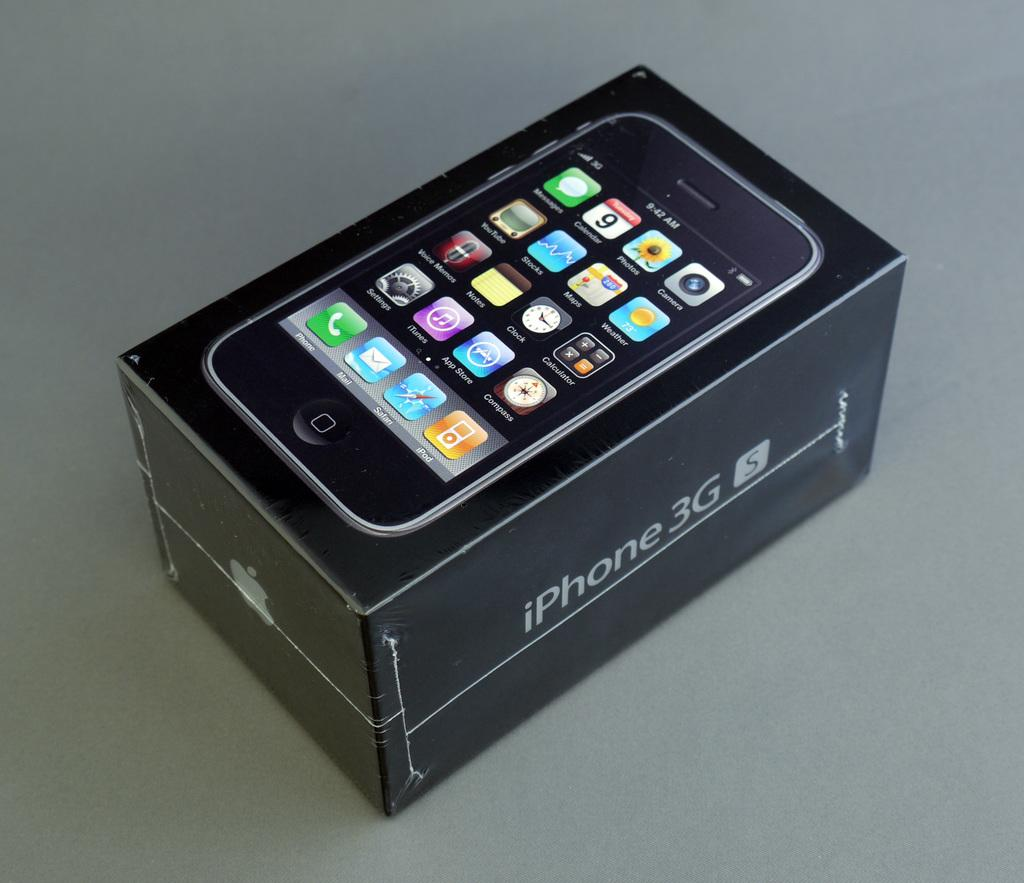<image>
Describe the image concisely. A phone sits on top of an iPhone 3G box. 